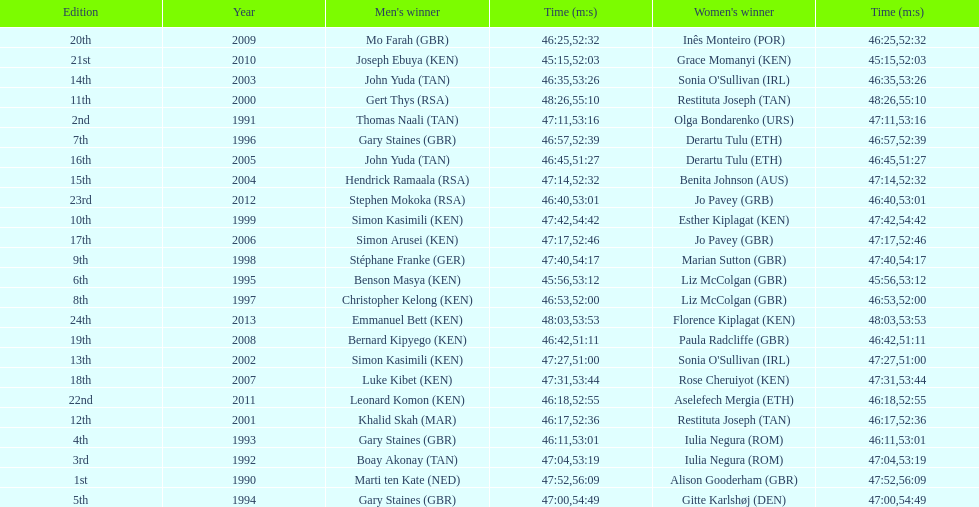Who has the fastest recorded finish for the men's bupa great south run, between 1990 and 2013? Joseph Ebuya (KEN). 